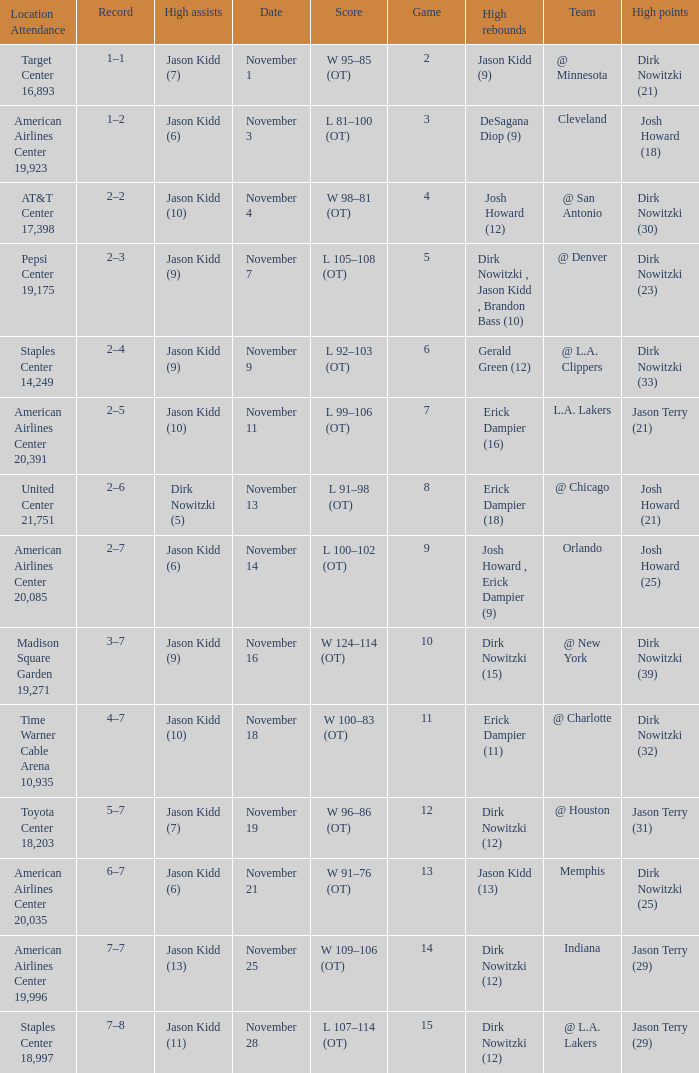What was the record on November 1? 1–1. Would you mind parsing the complete table? {'header': ['Location Attendance', 'Record', 'High assists', 'Date', 'Score', 'Game', 'High rebounds', 'Team', 'High points'], 'rows': [['Target Center 16,893', '1–1', 'Jason Kidd (7)', 'November 1', 'W 95–85 (OT)', '2', 'Jason Kidd (9)', '@ Minnesota', 'Dirk Nowitzki (21)'], ['American Airlines Center 19,923', '1–2', 'Jason Kidd (6)', 'November 3', 'L 81–100 (OT)', '3', 'DeSagana Diop (9)', 'Cleveland', 'Josh Howard (18)'], ['AT&T Center 17,398', '2–2', 'Jason Kidd (10)', 'November 4', 'W 98–81 (OT)', '4', 'Josh Howard (12)', '@ San Antonio', 'Dirk Nowitzki (30)'], ['Pepsi Center 19,175', '2–3', 'Jason Kidd (9)', 'November 7', 'L 105–108 (OT)', '5', 'Dirk Nowitzki , Jason Kidd , Brandon Bass (10)', '@ Denver', 'Dirk Nowitzki (23)'], ['Staples Center 14,249', '2–4', 'Jason Kidd (9)', 'November 9', 'L 92–103 (OT)', '6', 'Gerald Green (12)', '@ L.A. Clippers', 'Dirk Nowitzki (33)'], ['American Airlines Center 20,391', '2–5', 'Jason Kidd (10)', 'November 11', 'L 99–106 (OT)', '7', 'Erick Dampier (16)', 'L.A. Lakers', 'Jason Terry (21)'], ['United Center 21,751', '2–6', 'Dirk Nowitzki (5)', 'November 13', 'L 91–98 (OT)', '8', 'Erick Dampier (18)', '@ Chicago', 'Josh Howard (21)'], ['American Airlines Center 20,085', '2–7', 'Jason Kidd (6)', 'November 14', 'L 100–102 (OT)', '9', 'Josh Howard , Erick Dampier (9)', 'Orlando', 'Josh Howard (25)'], ['Madison Square Garden 19,271', '3–7', 'Jason Kidd (9)', 'November 16', 'W 124–114 (OT)', '10', 'Dirk Nowitzki (15)', '@ New York', 'Dirk Nowitzki (39)'], ['Time Warner Cable Arena 10,935', '4–7', 'Jason Kidd (10)', 'November 18', 'W 100–83 (OT)', '11', 'Erick Dampier (11)', '@ Charlotte', 'Dirk Nowitzki (32)'], ['Toyota Center 18,203', '5–7', 'Jason Kidd (7)', 'November 19', 'W 96–86 (OT)', '12', 'Dirk Nowitzki (12)', '@ Houston', 'Jason Terry (31)'], ['American Airlines Center 20,035', '6–7', 'Jason Kidd (6)', 'November 21', 'W 91–76 (OT)', '13', 'Jason Kidd (13)', 'Memphis', 'Dirk Nowitzki (25)'], ['American Airlines Center 19,996', '7–7', 'Jason Kidd (13)', 'November 25', 'W 109–106 (OT)', '14', 'Dirk Nowitzki (12)', 'Indiana', 'Jason Terry (29)'], ['Staples Center 18,997', '7–8', 'Jason Kidd (11)', 'November 28', 'L 107–114 (OT)', '15', 'Dirk Nowitzki (12)', '@ L.A. Lakers', 'Jason Terry (29)']]} 